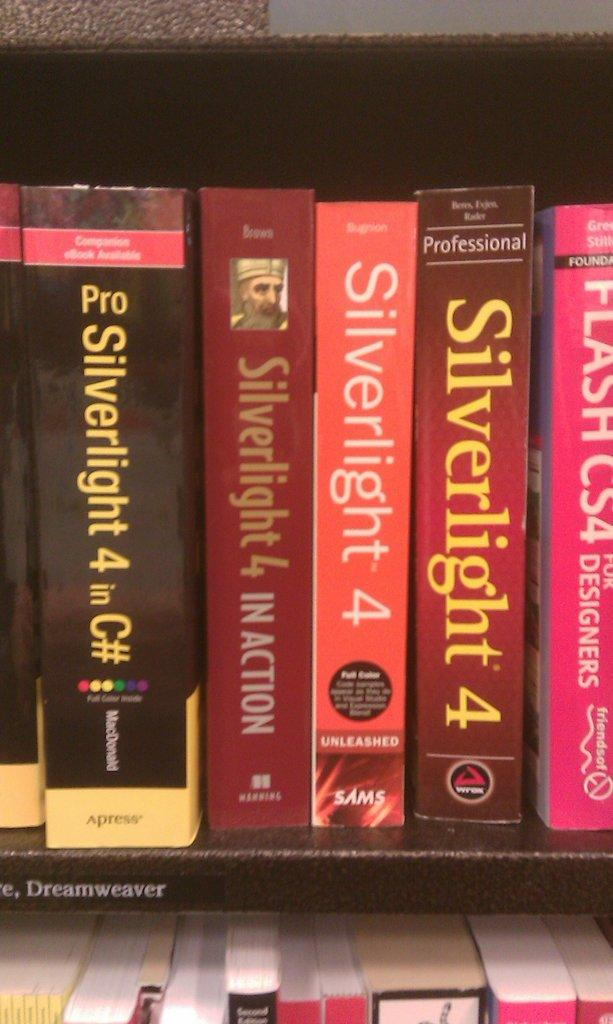<image>
Summarize the visual content of the image. Books are lined up together including one titled Silverlight 4. 